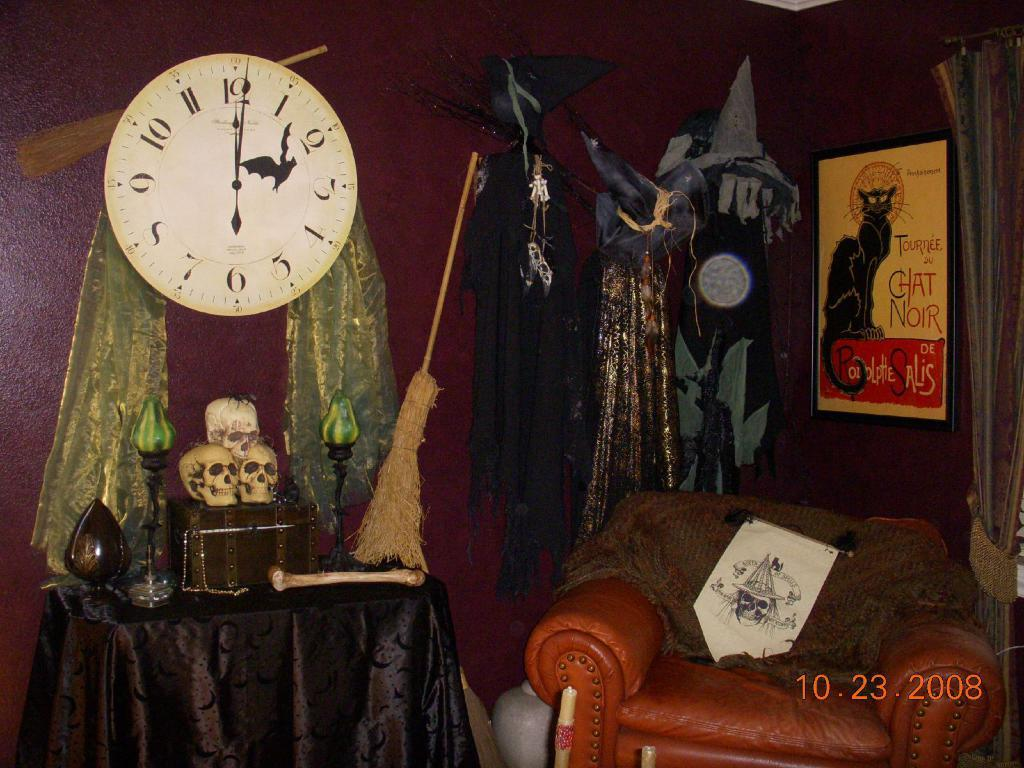<image>
Offer a succinct explanation of the picture presented. Inside of a store which has a poster of a cat and says "CAT NOIR". 